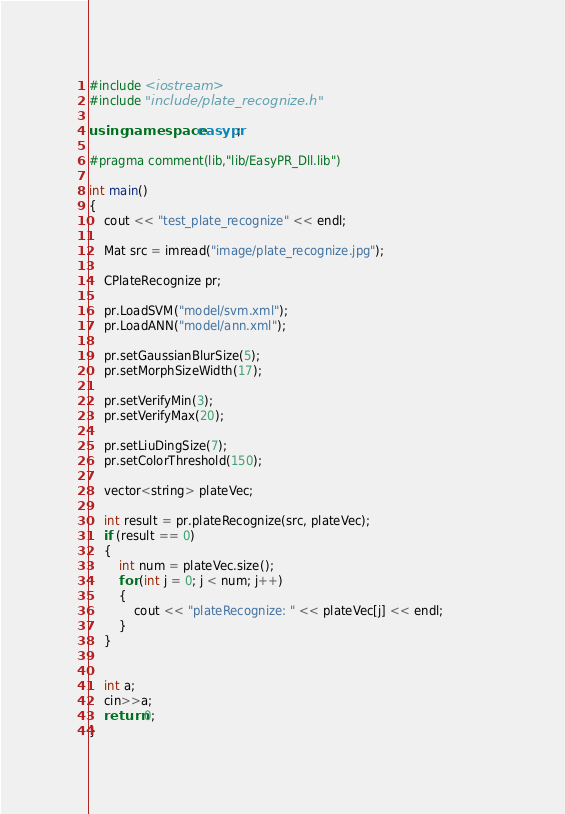<code> <loc_0><loc_0><loc_500><loc_500><_C++_>#include <iostream>
#include "include/plate_recognize.h"

using namespace easypr;

#pragma comment(lib,"lib/EasyPR_Dll.lib")

int main()
{
	cout << "test_plate_recognize" << endl;

	Mat src = imread("image/plate_recognize.jpg");

	CPlateRecognize pr;

	pr.LoadSVM("model/svm.xml");
	pr.LoadANN("model/ann.xml");

	pr.setGaussianBlurSize(5);
	pr.setMorphSizeWidth(17);

	pr.setVerifyMin(3);
	pr.setVerifyMax(20);

	pr.setLiuDingSize(7);
	pr.setColorThreshold(150);

	vector<string> plateVec;

	int result = pr.plateRecognize(src, plateVec);
	if (result == 0)
	{
		int num = plateVec.size();
		for (int j = 0; j < num; j++)
		{
			cout << "plateRecognize: " << plateVec[j] << endl;			
		}
	}


	int a;
	cin>>a;
	return 0;
}</code> 